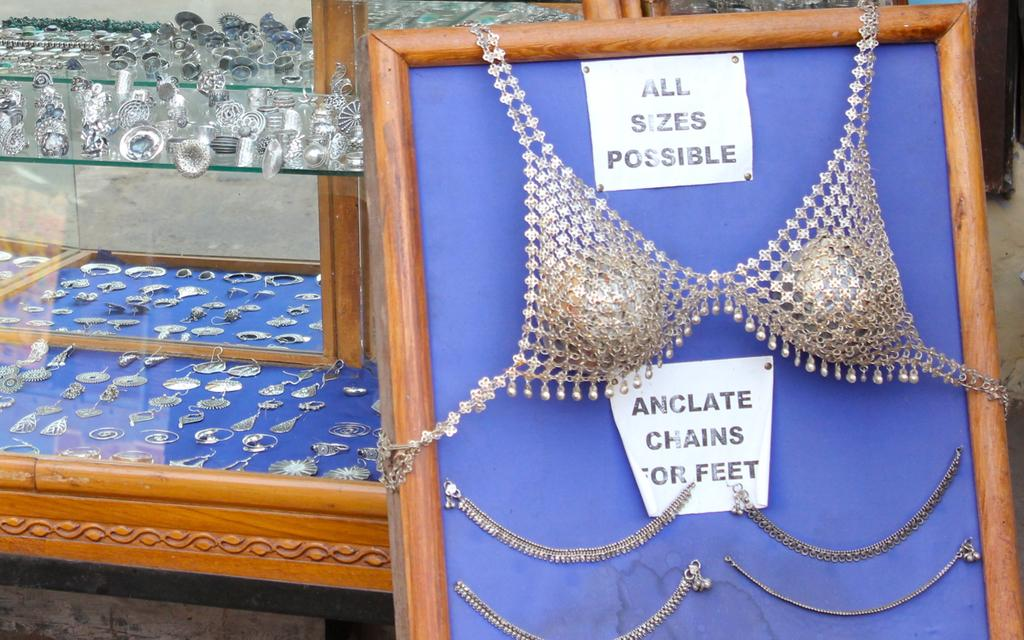What type of objects can be seen in the image? There are ornaments, papers on a board, and a glass object in the image. What surface are the papers on in the image? The papers are on a board in the image. What type of furniture is present in the image? There is a table in the image. How many eggs are being whipped in the image? There are no eggs or whipping activity present in the image. 